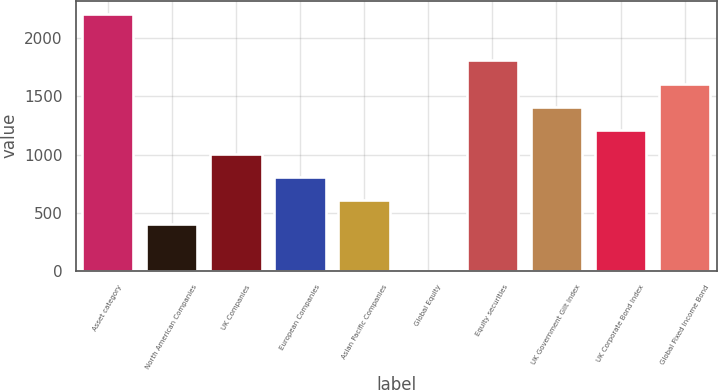<chart> <loc_0><loc_0><loc_500><loc_500><bar_chart><fcel>Asset category<fcel>North American Companies<fcel>UK Companies<fcel>European Companies<fcel>Asian Pacific Companies<fcel>Global Equity<fcel>Equity securities<fcel>UK Government Gilt Index<fcel>UK Corporate Bond Index<fcel>Global Fixed Income Bond<nl><fcel>2213.1<fcel>403.2<fcel>1006.5<fcel>805.4<fcel>604.3<fcel>1<fcel>1810.9<fcel>1408.7<fcel>1207.6<fcel>1609.8<nl></chart> 